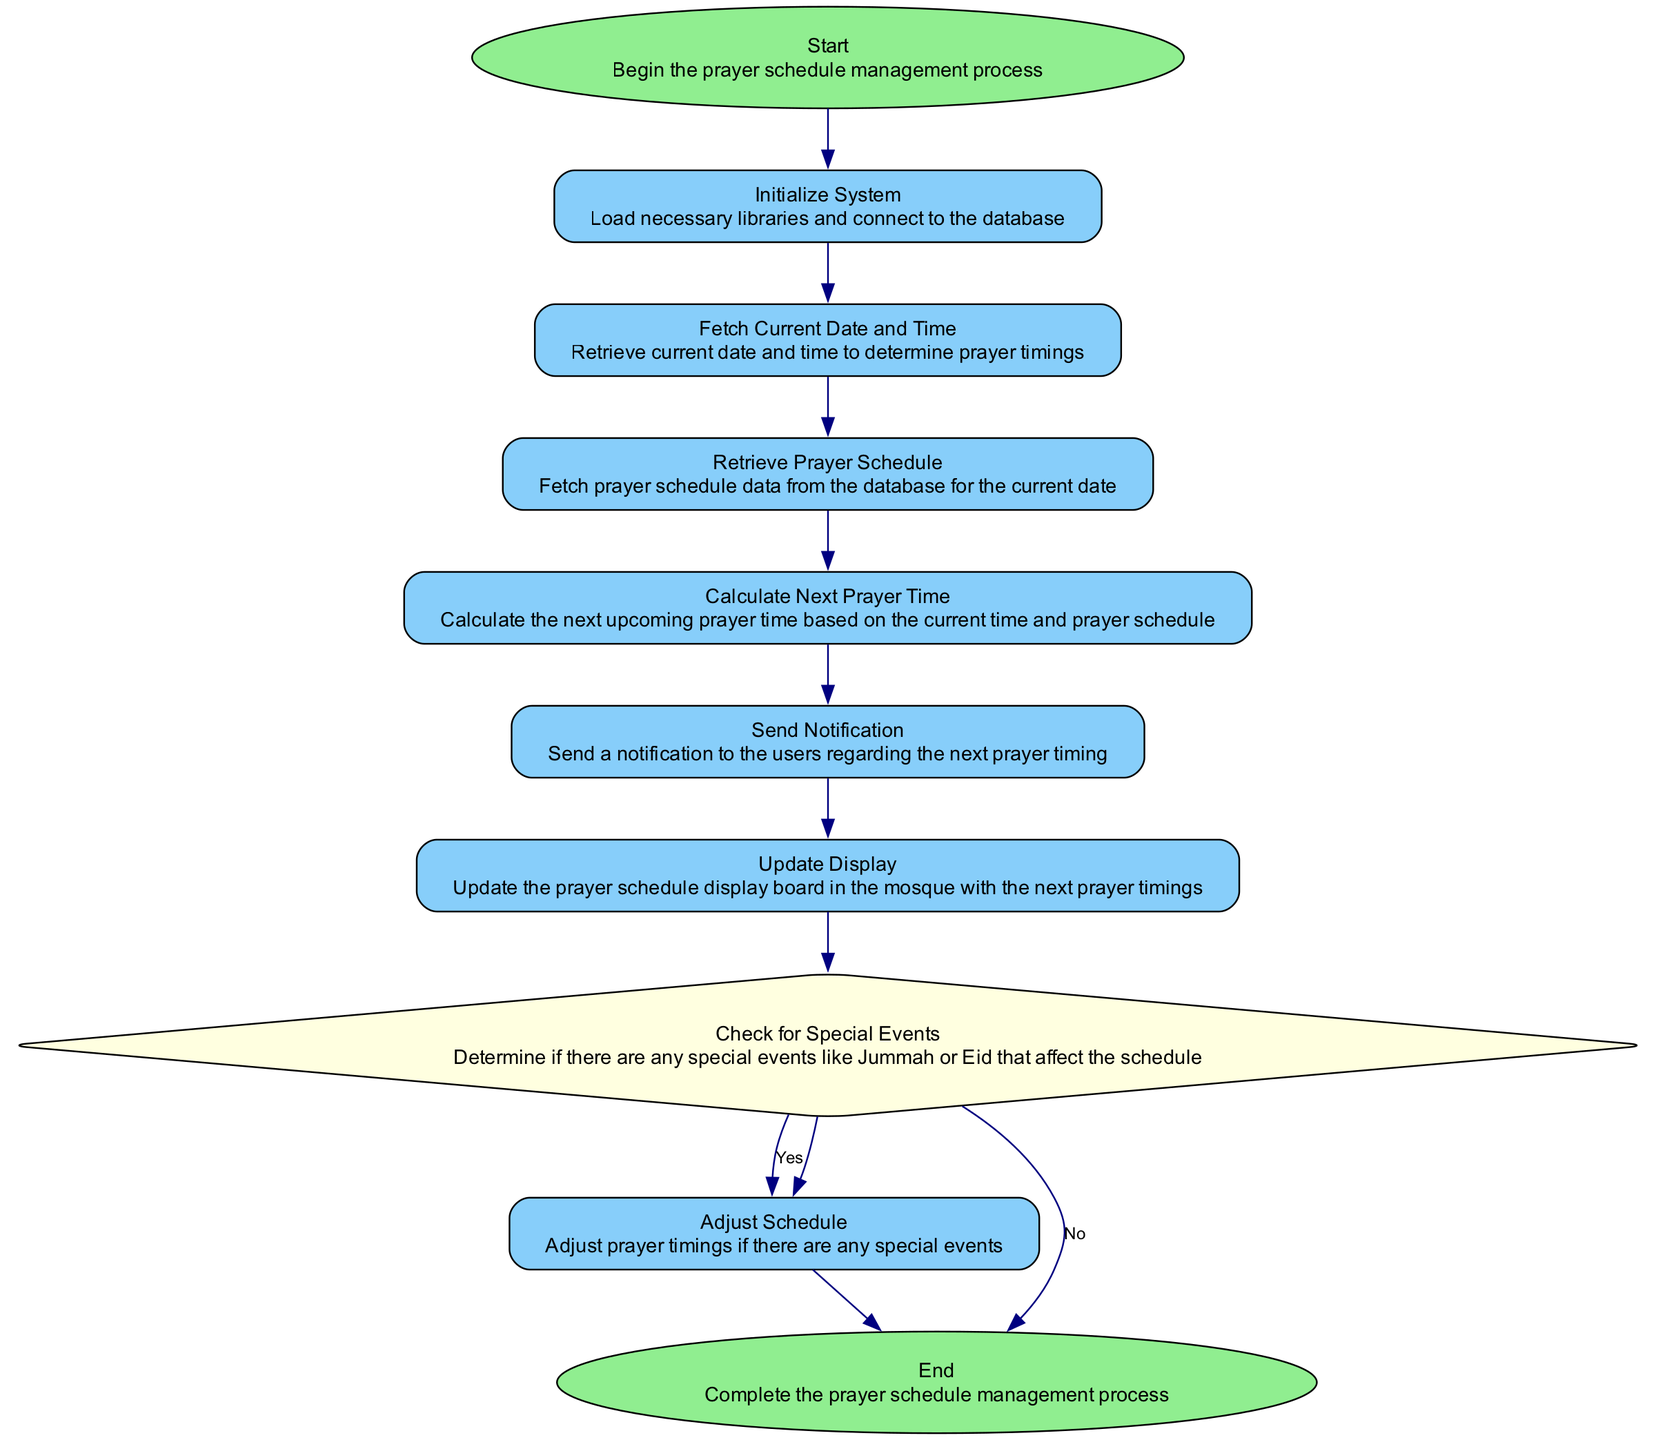What is the first step in the diagram? The first step in the diagram is labeled "Start", indicating the beginning of the prayer schedule management process.
Answer: Start What follows after "Initialize System"? The step that follows "Initialize System" is "Fetch Current Date and Time", which means the system retrieves the current time to determine prayer timings.
Answer: Fetch Current Date and Time How many nodes are in the diagram? There are ten nodes in the diagram, each representing a specific step in the prayer schedule management process.
Answer: Ten What is checked for in the "Check for Special Events" step? The step "Check for Special Events" determines if there are any special events like Jummah or Eid that might affect the prayer schedule.
Answer: Special events What happens if there are no special events after "Check for Special Events"? If there are no special events, the flow continues to "Update Display", indicating that the prayer schedule will be updated without adjustments.
Answer: Update Display Which step is conditional in nature? The "Check for Special Events" step is conditional as it leads to two outcomes, either adjusting the schedule or moving to "End".
Answer: Check for Special Events What is the last step in the diagram? The last step in the diagram is labeled "End", which signifies the completion of the prayer schedule management process.
Answer: End How is the notification sent in the flow? The notification is sent after calculating the next prayer time, specifically in the "Send Notification" step.
Answer: Send Notification What is the role of "Update Display" in the diagram? The "Update Display" step updates the prayer schedule display board in the mosque with the next prayer timings, making it essential for communication to attendees.
Answer: Update Display 